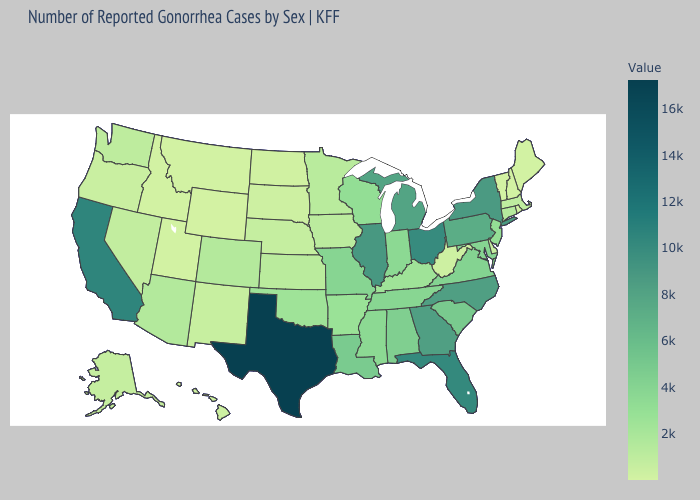Does Maryland have the lowest value in the USA?
Write a very short answer. No. Which states hav the highest value in the MidWest?
Quick response, please. Ohio. Among the states that border Colorado , which have the highest value?
Answer briefly. Oklahoma. 